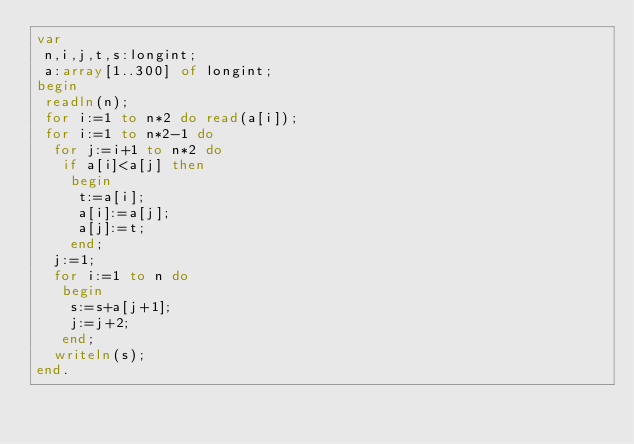Convert code to text. <code><loc_0><loc_0><loc_500><loc_500><_Pascal_>var
 n,i,j,t,s:longint;
 a:array[1..300] of longint;
begin
 readln(n);
 for i:=1 to n*2 do read(a[i]);
 for i:=1 to n*2-1 do 
  for j:=i+1 to n*2 do 
   if a[i]<a[j] then 
    begin
     t:=a[i];
     a[i]:=a[j];
     a[j]:=t;
    end;
  j:=1;
  for i:=1 to n do
   begin
    s:=s+a[j+1];
    j:=j+2;
   end;
  writeln(s);
end.</code> 